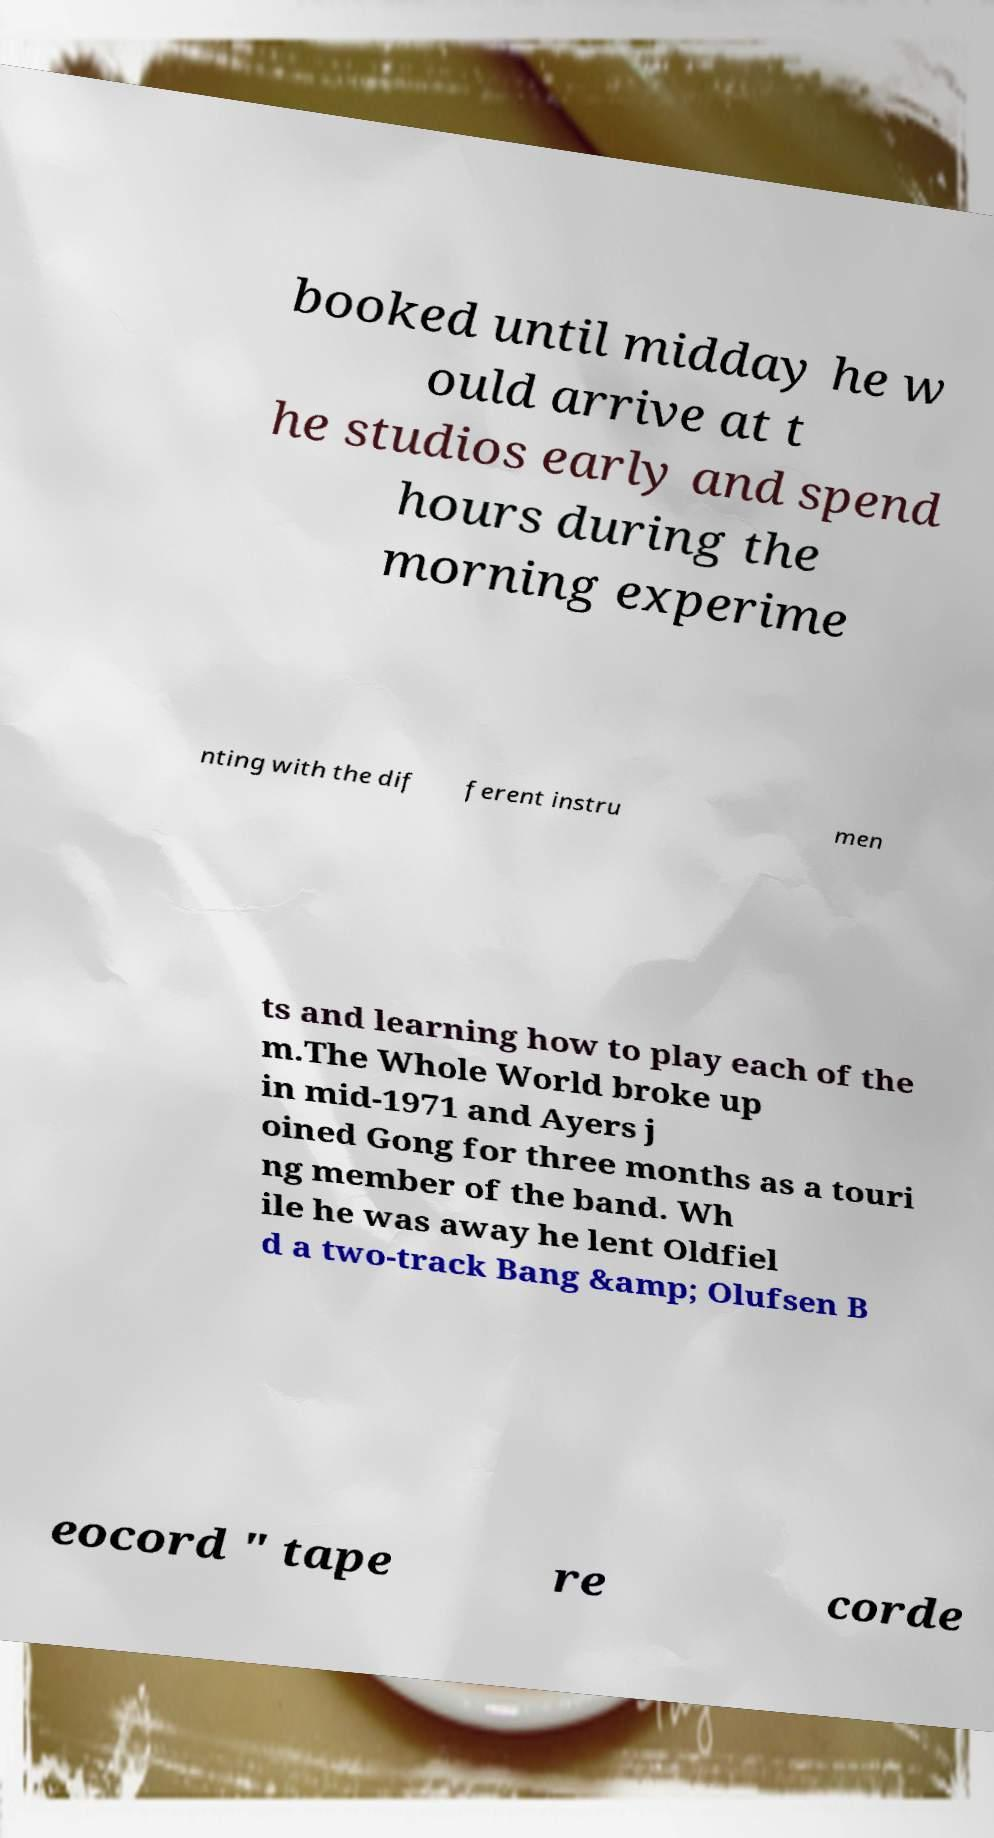Could you assist in decoding the text presented in this image and type it out clearly? booked until midday he w ould arrive at t he studios early and spend hours during the morning experime nting with the dif ferent instru men ts and learning how to play each of the m.The Whole World broke up in mid-1971 and Ayers j oined Gong for three months as a touri ng member of the band. Wh ile he was away he lent Oldfiel d a two-track Bang &amp; Olufsen B eocord " tape re corde 